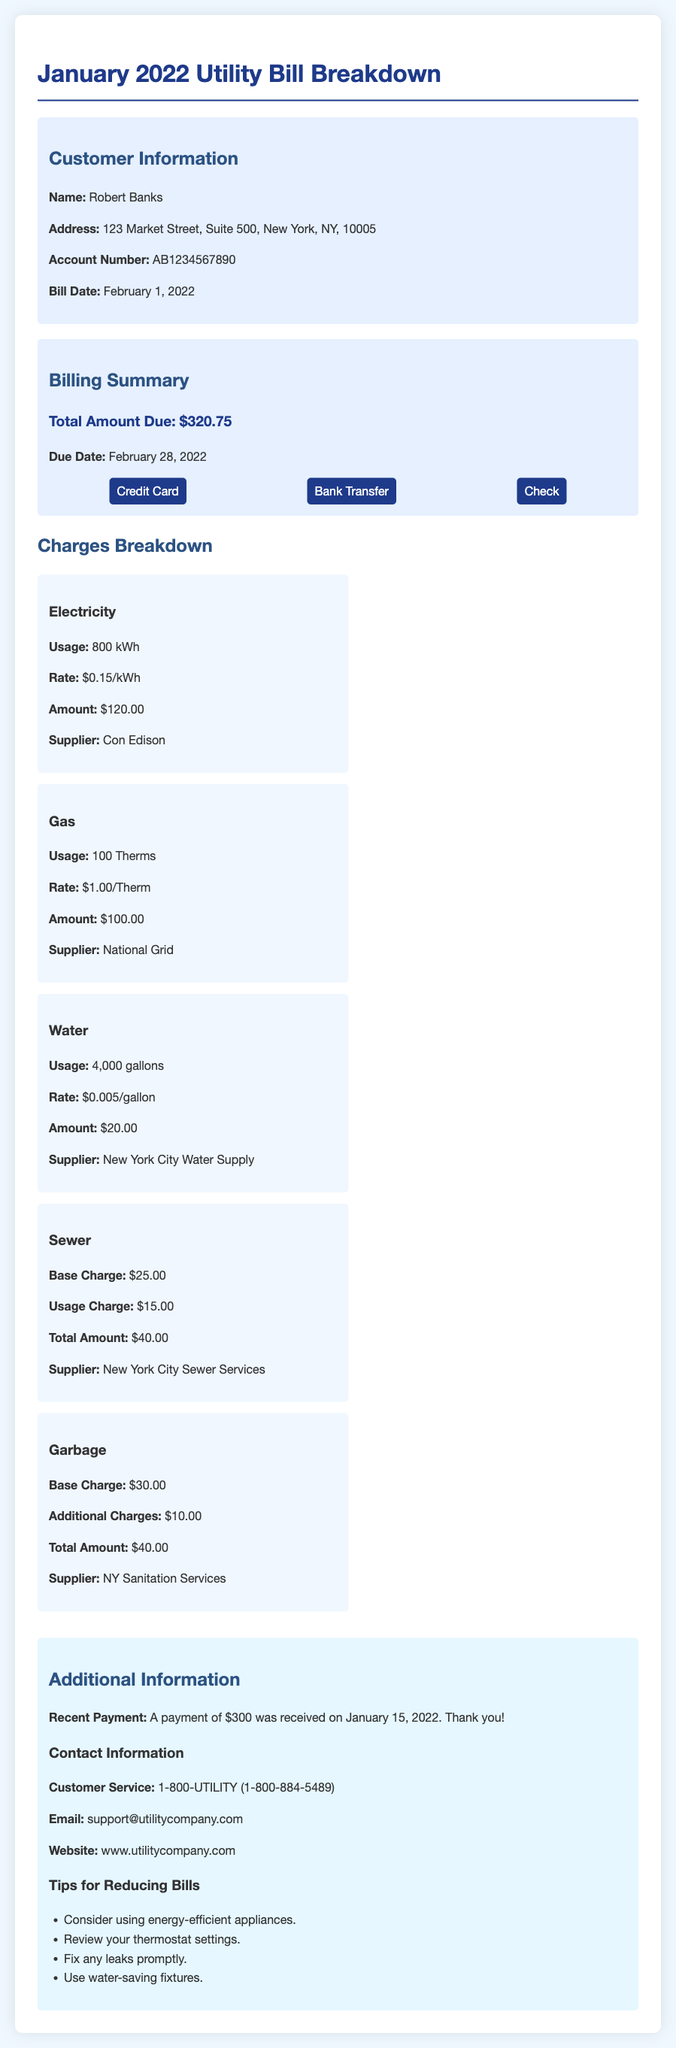What is the account number? The account number is specifically mentioned in the customer information section of the document.
Answer: AB1234567890 What is the due date for the bill? The due date for the bill is clearly stated in the billing summary.
Answer: February 28, 2022 How much was the recent payment? The amount of the recent payment is detailed in the additional information section of the document.
Answer: $300 What is the total amount due? The total amount due is explicitly listed in the billing summary section of the document.
Answer: $320.75 How many kilowatt-hours of electricity were used? The usage of electricity is broken down in the charges section, specifying the total kilowatt-hours.
Answer: 800 kWh What is the rate per therm for gas? The rate for gas is provided alongside the gas usage in the charges breakdown.
Answer: $1.00/Therm What is the supplier for water? The supplier for water is identified in the charges breakdown section for water.
Answer: New York City Water Supply What are the additional charges for garbage? The additional charges for garbage are specifically outlined in the charges section.
Answer: $10.00 Which payment methods are available? The available payment methods are listed in the billing summary section of the document.
Answer: Credit Card, Bank Transfer, Check 